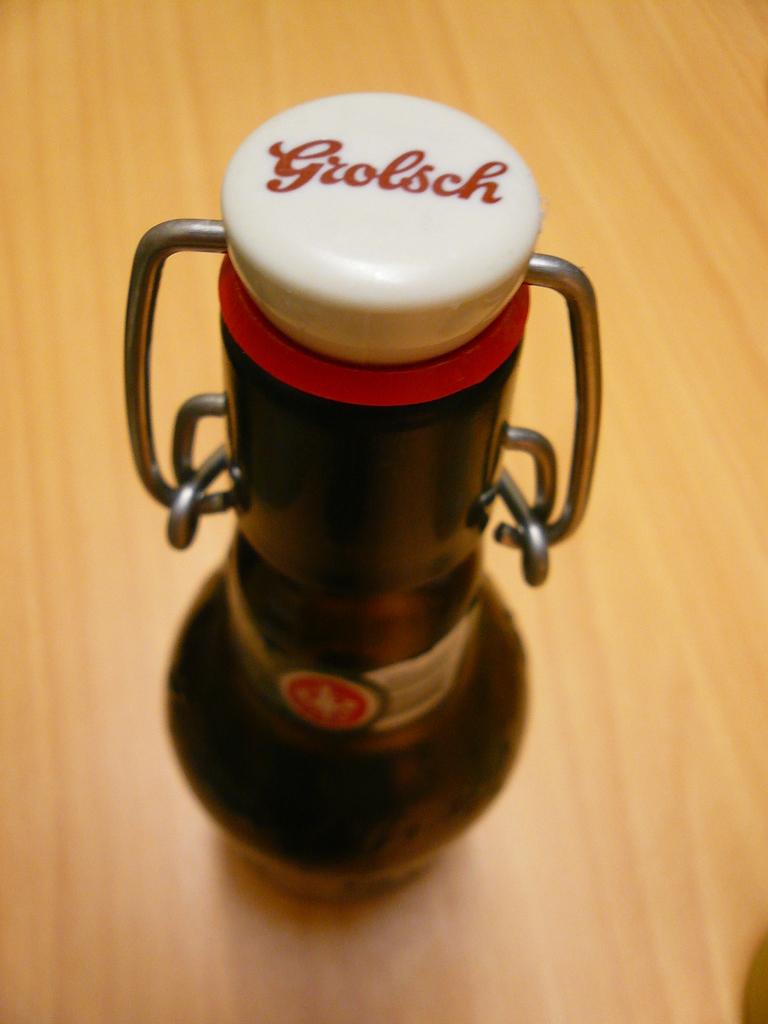What's written on the bottle's cap?
Make the answer very short. Grolsch. 